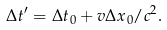<formula> <loc_0><loc_0><loc_500><loc_500>\Delta t ^ { \prime } = \Delta t _ { 0 } + { v \Delta x _ { 0 } } / { c ^ { 2 } } .</formula> 